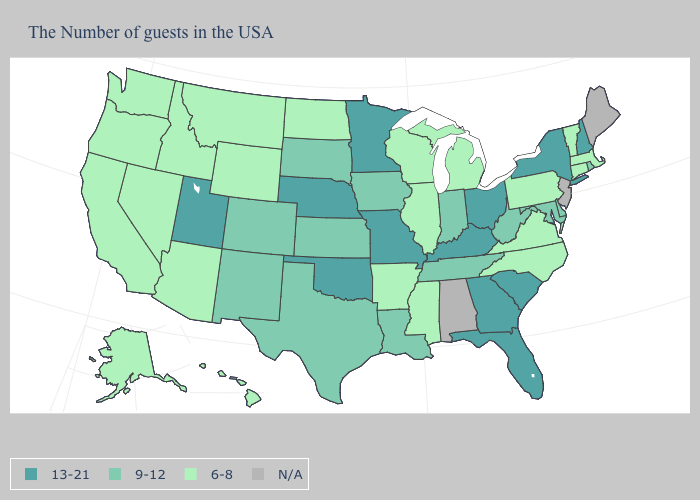What is the value of Idaho?
Be succinct. 6-8. What is the value of Rhode Island?
Quick response, please. 9-12. What is the value of Rhode Island?
Keep it brief. 9-12. Name the states that have a value in the range 6-8?
Short answer required. Massachusetts, Vermont, Connecticut, Pennsylvania, Virginia, North Carolina, Michigan, Wisconsin, Illinois, Mississippi, Arkansas, North Dakota, Wyoming, Montana, Arizona, Idaho, Nevada, California, Washington, Oregon, Alaska, Hawaii. Does Missouri have the highest value in the USA?
Short answer required. Yes. How many symbols are there in the legend?
Concise answer only. 4. Among the states that border Colorado , does Oklahoma have the highest value?
Be succinct. Yes. What is the value of Wyoming?
Short answer required. 6-8. Among the states that border New Mexico , does Oklahoma have the lowest value?
Be succinct. No. Name the states that have a value in the range 9-12?
Short answer required. Rhode Island, Delaware, Maryland, West Virginia, Indiana, Tennessee, Louisiana, Iowa, Kansas, Texas, South Dakota, Colorado, New Mexico. What is the value of Indiana?
Keep it brief. 9-12. Among the states that border Arkansas , which have the highest value?
Concise answer only. Missouri, Oklahoma. What is the highest value in states that border Oklahoma?
Be succinct. 13-21. What is the highest value in the MidWest ?
Concise answer only. 13-21. 